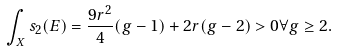Convert formula to latex. <formula><loc_0><loc_0><loc_500><loc_500>\int _ { X } s _ { 2 } ( E ) = \frac { 9 r ^ { 2 } } { 4 } ( g - 1 ) + 2 r ( g - 2 ) > 0 \forall g \geq 2 .</formula> 